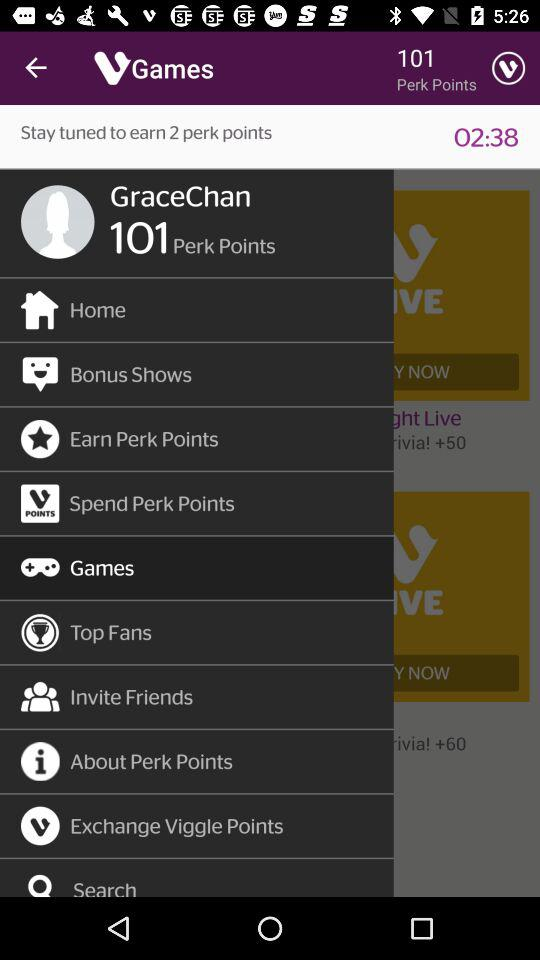How long do we have to stay tuned to earn 2 perk points? You have to stay tuned for 2 minutes 38 seconds to earn 2 perk points. 